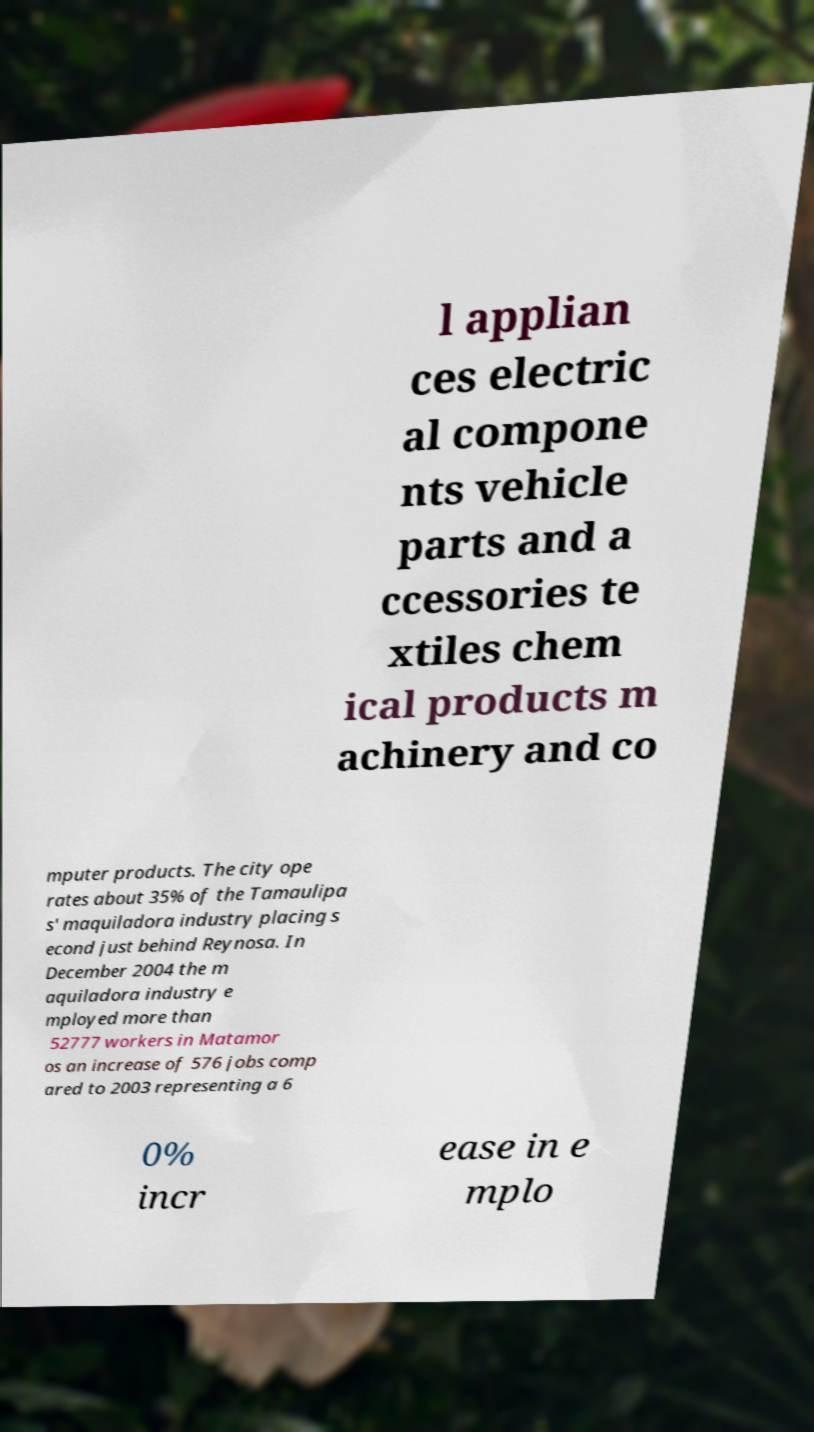There's text embedded in this image that I need extracted. Can you transcribe it verbatim? l applian ces electric al compone nts vehicle parts and a ccessories te xtiles chem ical products m achinery and co mputer products. The city ope rates about 35% of the Tamaulipa s' maquiladora industry placing s econd just behind Reynosa. In December 2004 the m aquiladora industry e mployed more than 52777 workers in Matamor os an increase of 576 jobs comp ared to 2003 representing a 6 0% incr ease in e mplo 